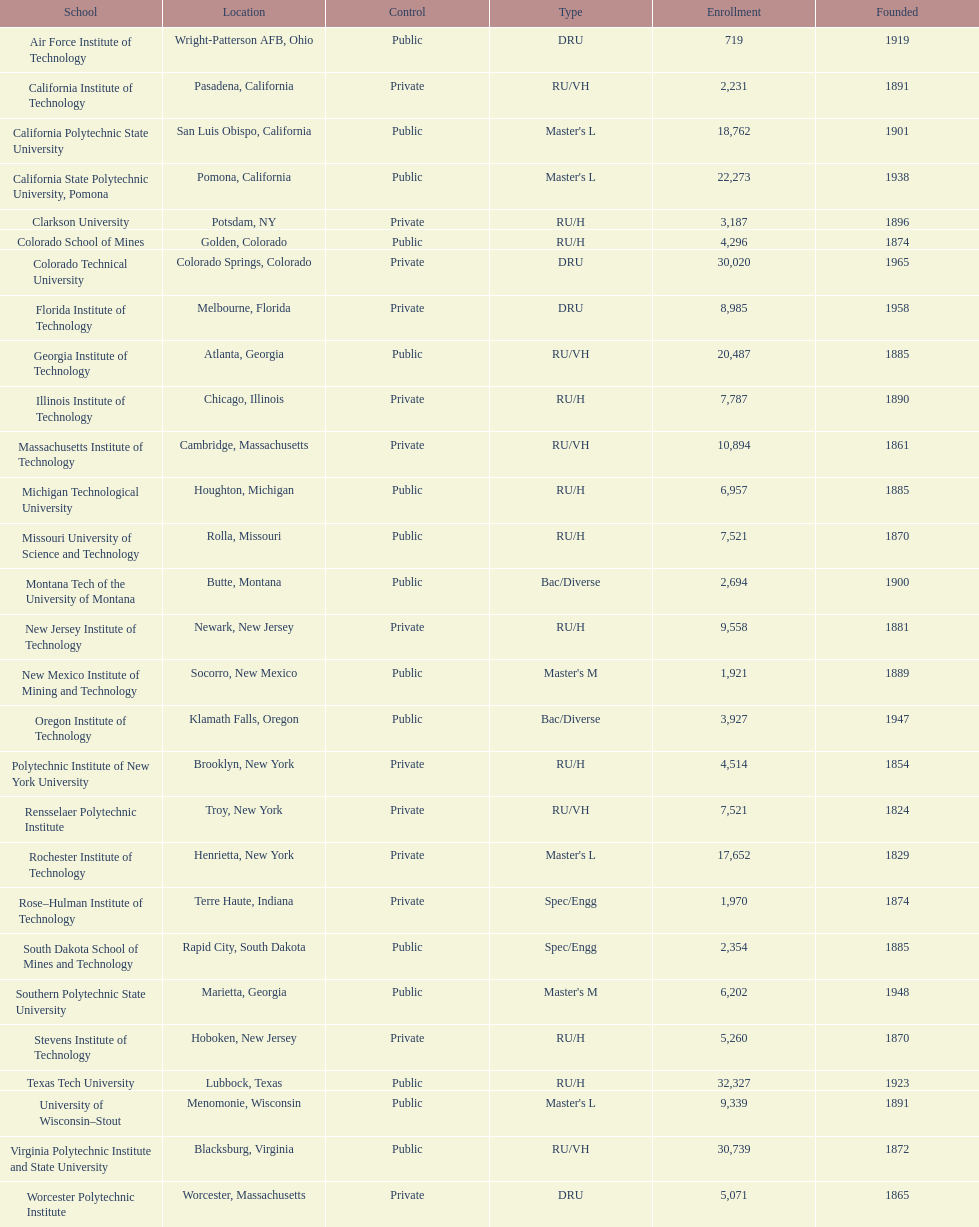How many of the colleges were positioned in california? 3. 